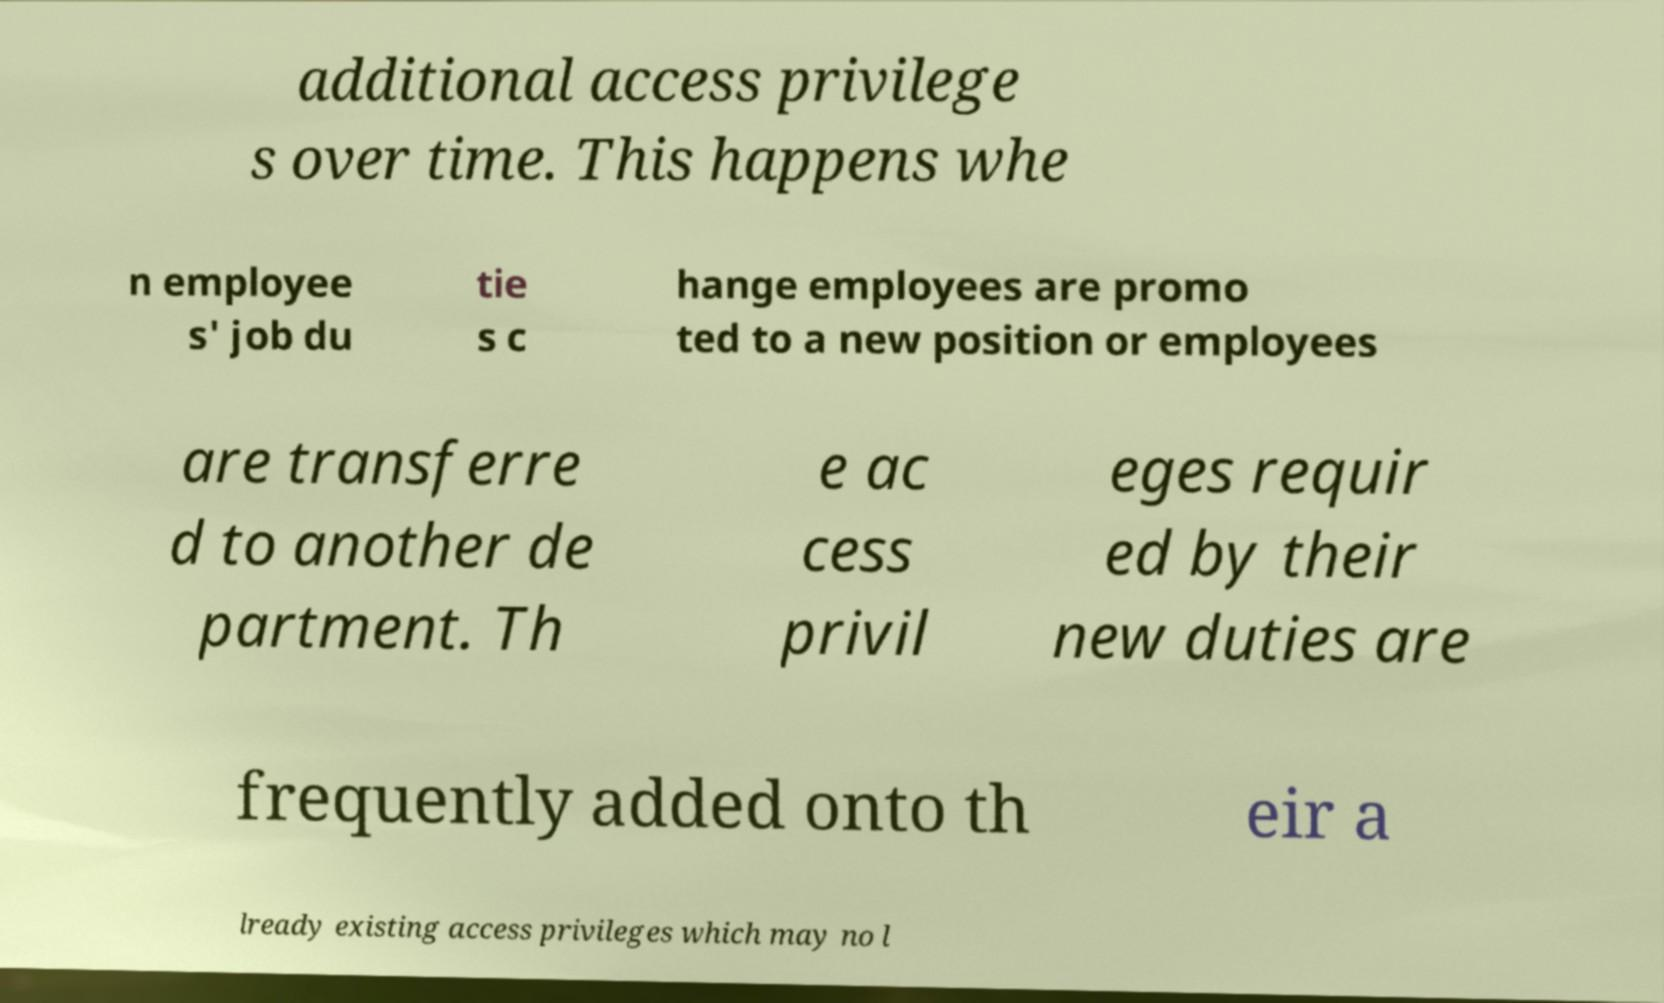Can you accurately transcribe the text from the provided image for me? additional access privilege s over time. This happens whe n employee s' job du tie s c hange employees are promo ted to a new position or employees are transferre d to another de partment. Th e ac cess privil eges requir ed by their new duties are frequently added onto th eir a lready existing access privileges which may no l 